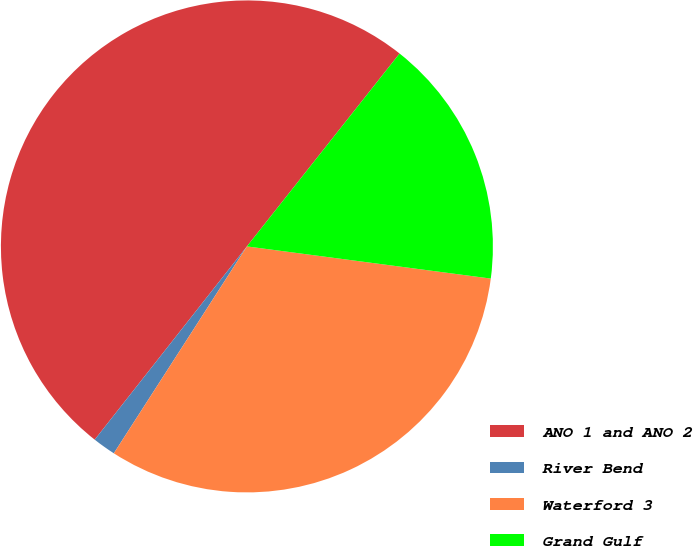Convert chart. <chart><loc_0><loc_0><loc_500><loc_500><pie_chart><fcel>ANO 1 and ANO 2<fcel>River Bend<fcel>Waterford 3<fcel>Grand Gulf<nl><fcel>50.04%<fcel>1.52%<fcel>32.01%<fcel>16.43%<nl></chart> 